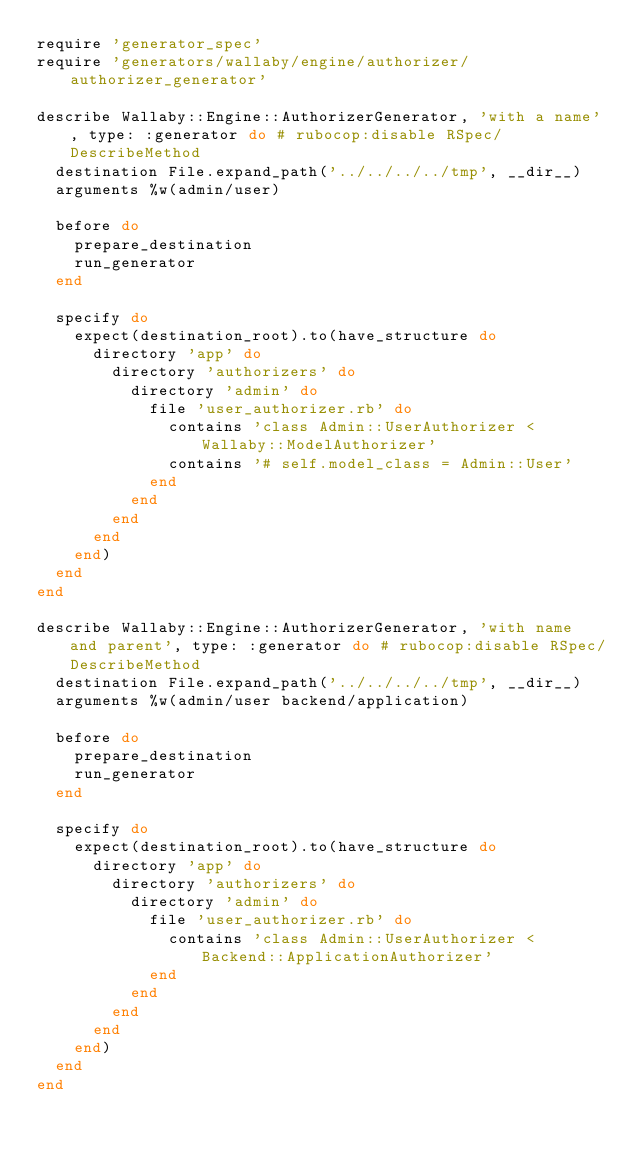<code> <loc_0><loc_0><loc_500><loc_500><_Ruby_>require 'generator_spec'
require 'generators/wallaby/engine/authorizer/authorizer_generator'

describe Wallaby::Engine::AuthorizerGenerator, 'with a name', type: :generator do # rubocop:disable RSpec/DescribeMethod
  destination File.expand_path('../../../../tmp', __dir__)
  arguments %w(admin/user)

  before do
    prepare_destination
    run_generator
  end

  specify do
    expect(destination_root).to(have_structure do
      directory 'app' do
        directory 'authorizers' do
          directory 'admin' do
            file 'user_authorizer.rb' do
              contains 'class Admin::UserAuthorizer < Wallaby::ModelAuthorizer'
              contains '# self.model_class = Admin::User'
            end
          end
        end
      end
    end)
  end
end

describe Wallaby::Engine::AuthorizerGenerator, 'with name and parent', type: :generator do # rubocop:disable RSpec/DescribeMethod
  destination File.expand_path('../../../../tmp', __dir__)
  arguments %w(admin/user backend/application)

  before do
    prepare_destination
    run_generator
  end

  specify do
    expect(destination_root).to(have_structure do
      directory 'app' do
        directory 'authorizers' do
          directory 'admin' do
            file 'user_authorizer.rb' do
              contains 'class Admin::UserAuthorizer < Backend::ApplicationAuthorizer'
            end
          end
        end
      end
    end)
  end
end
</code> 